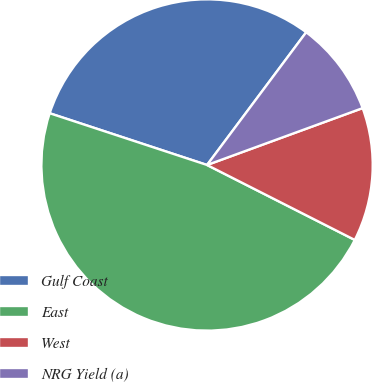Convert chart to OTSL. <chart><loc_0><loc_0><loc_500><loc_500><pie_chart><fcel>Gulf Coast<fcel>East<fcel>West<fcel>NRG Yield (a)<nl><fcel>30.15%<fcel>47.58%<fcel>13.05%<fcel>9.21%<nl></chart> 